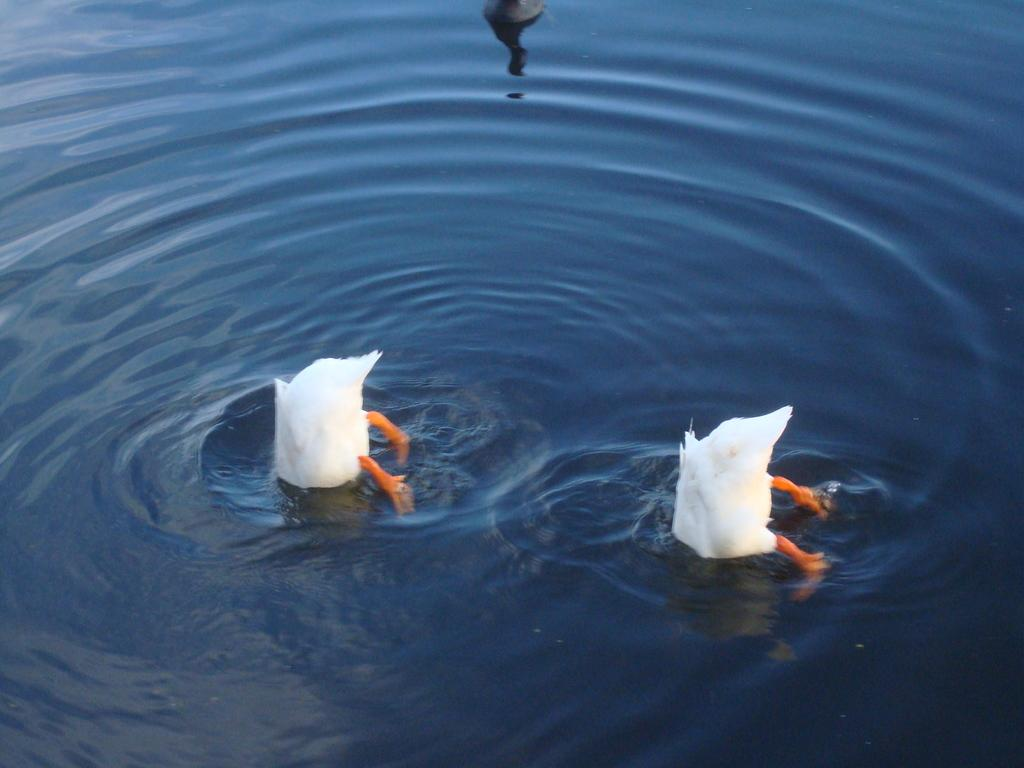What type of animals are in the foreground of the image? There are two white ducks in the foreground of the image. Where are the ducks located? The ducks are in the water. Are there any other ducks in the image? Yes, there is a black-colored duck in the image. Where is the black-colored duck positioned? The black-colored duck is on the top side of the image. What type of vest is the duck wearing in the image? Ducks do not wear vests, so there is no vest present in the image. Can you read any letters on the duck's suit in the image? Ducks do not wear suits, and there are no letters or suits present in the image. 